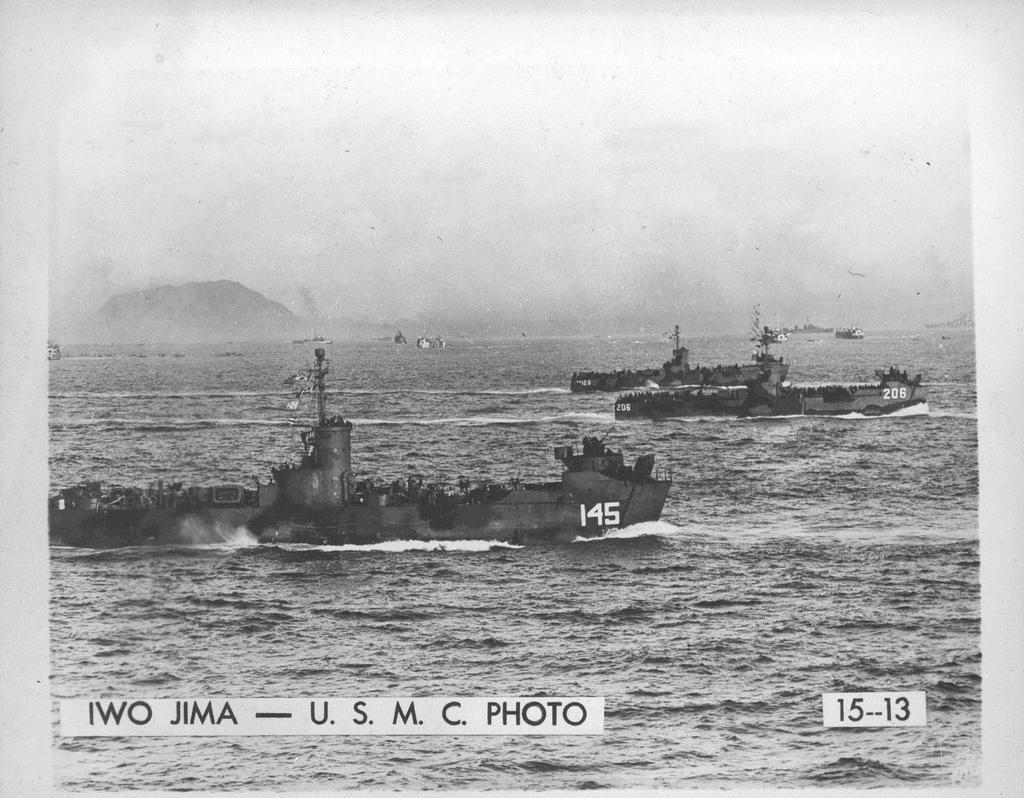What number is on the ship at the front?
Provide a short and direct response. 145. Who does this photo belong to?
Make the answer very short. Usmc. 